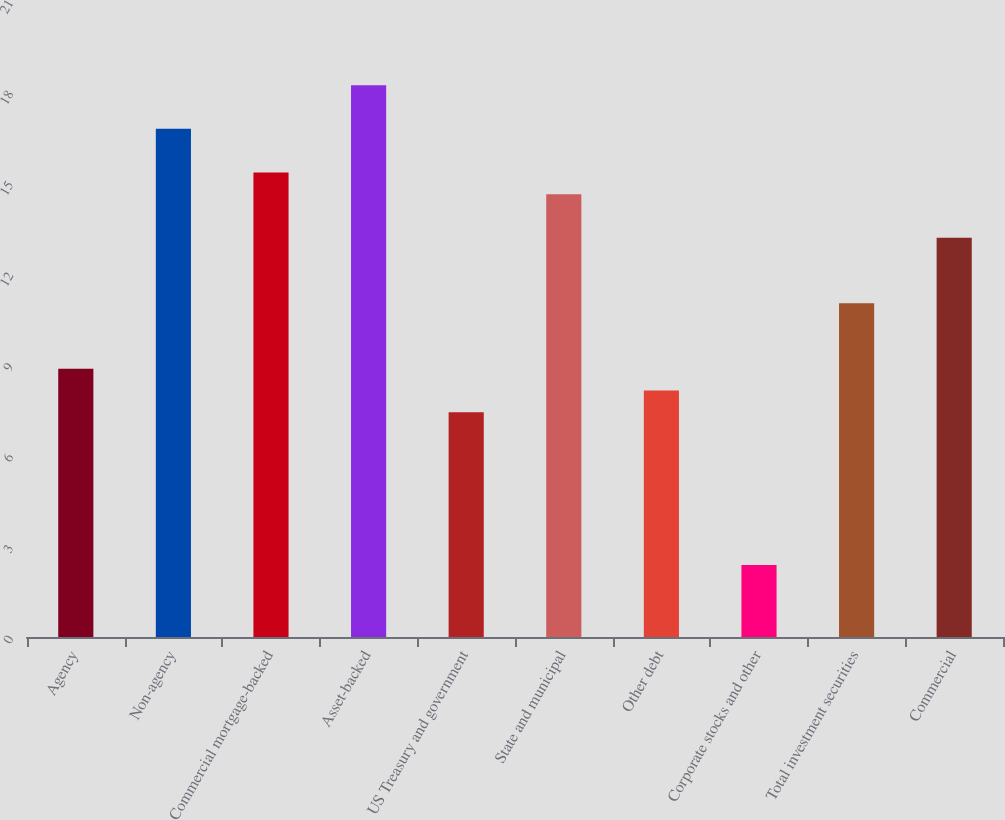<chart> <loc_0><loc_0><loc_500><loc_500><bar_chart><fcel>Agency<fcel>Non-agency<fcel>Commercial mortgage-backed<fcel>Asset-backed<fcel>US Treasury and government<fcel>State and municipal<fcel>Other debt<fcel>Corporate stocks and other<fcel>Total investment securities<fcel>Commercial<nl><fcel>8.86<fcel>16.78<fcel>15.34<fcel>18.22<fcel>7.42<fcel>14.62<fcel>8.14<fcel>2.38<fcel>11.02<fcel>13.18<nl></chart> 